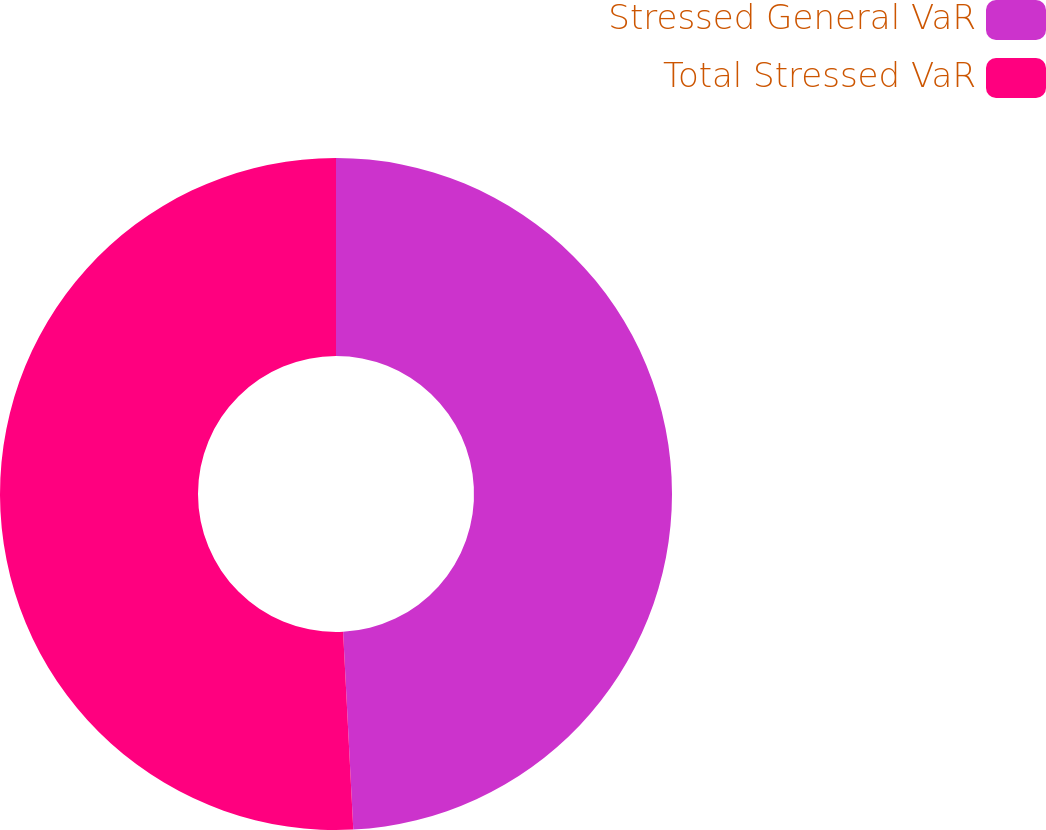<chart> <loc_0><loc_0><loc_500><loc_500><pie_chart><fcel>Stressed General VaR<fcel>Total Stressed VaR<nl><fcel>49.18%<fcel>50.82%<nl></chart> 